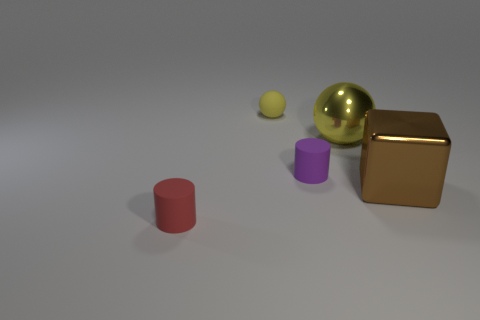Subtract 1 balls. How many balls are left? 1 Subtract all balls. How many objects are left? 3 Subtract all cyan blocks. How many blue cylinders are left? 0 Add 4 brown cubes. How many brown cubes are left? 5 Add 4 tiny yellow metal cylinders. How many tiny yellow metal cylinders exist? 4 Add 2 big cyan cylinders. How many objects exist? 7 Subtract 0 red spheres. How many objects are left? 5 Subtract all yellow blocks. Subtract all brown cylinders. How many blocks are left? 1 Subtract all blocks. Subtract all tiny red things. How many objects are left? 3 